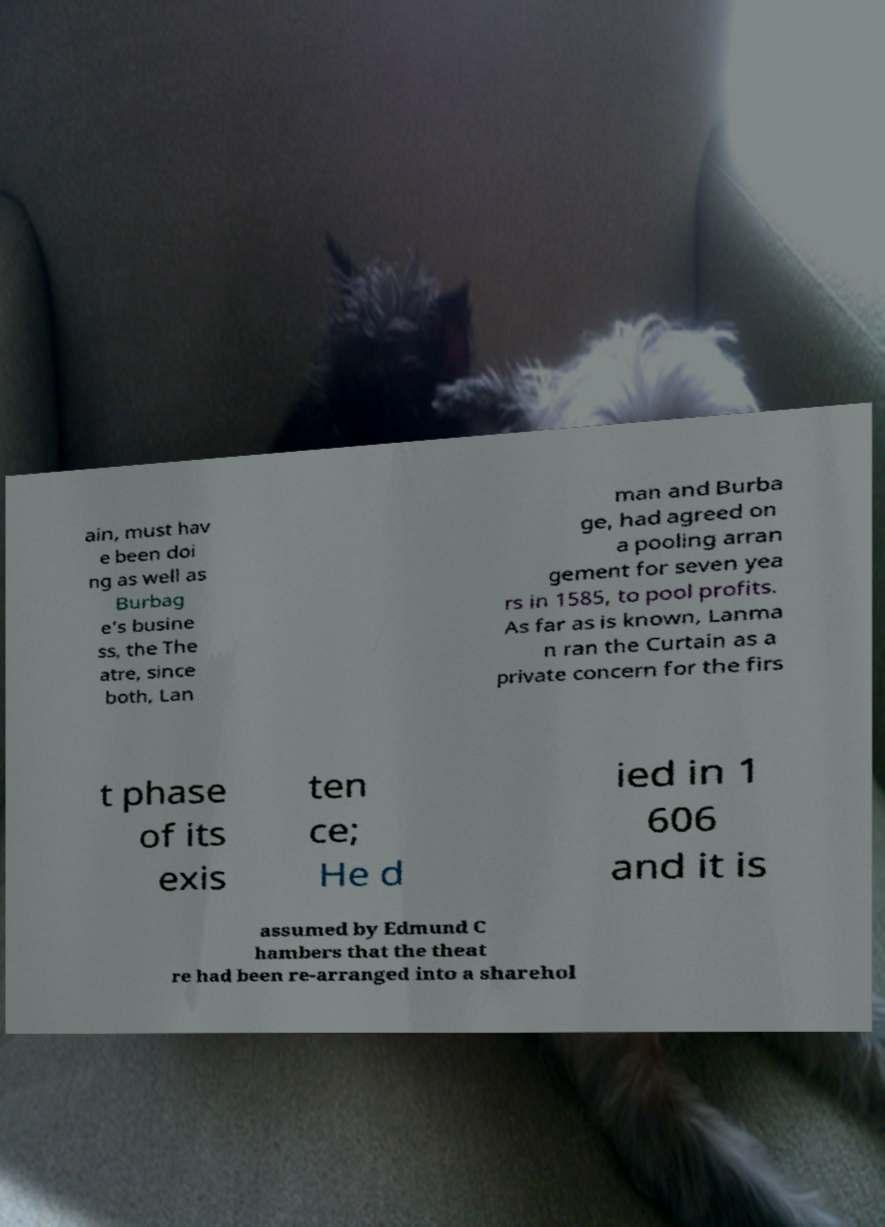Can you read and provide the text displayed in the image?This photo seems to have some interesting text. Can you extract and type it out for me? ain, must hav e been doi ng as well as Burbag e’s busine ss, the The atre, since both, Lan man and Burba ge, had agreed on a pooling arran gement for seven yea rs in 1585, to pool profits. As far as is known, Lanma n ran the Curtain as a private concern for the firs t phase of its exis ten ce; He d ied in 1 606 and it is assumed by Edmund C hambers that the theat re had been re-arranged into a sharehol 